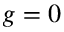Convert formula to latex. <formula><loc_0><loc_0><loc_500><loc_500>g = 0</formula> 